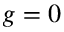Convert formula to latex. <formula><loc_0><loc_0><loc_500><loc_500>g = 0</formula> 